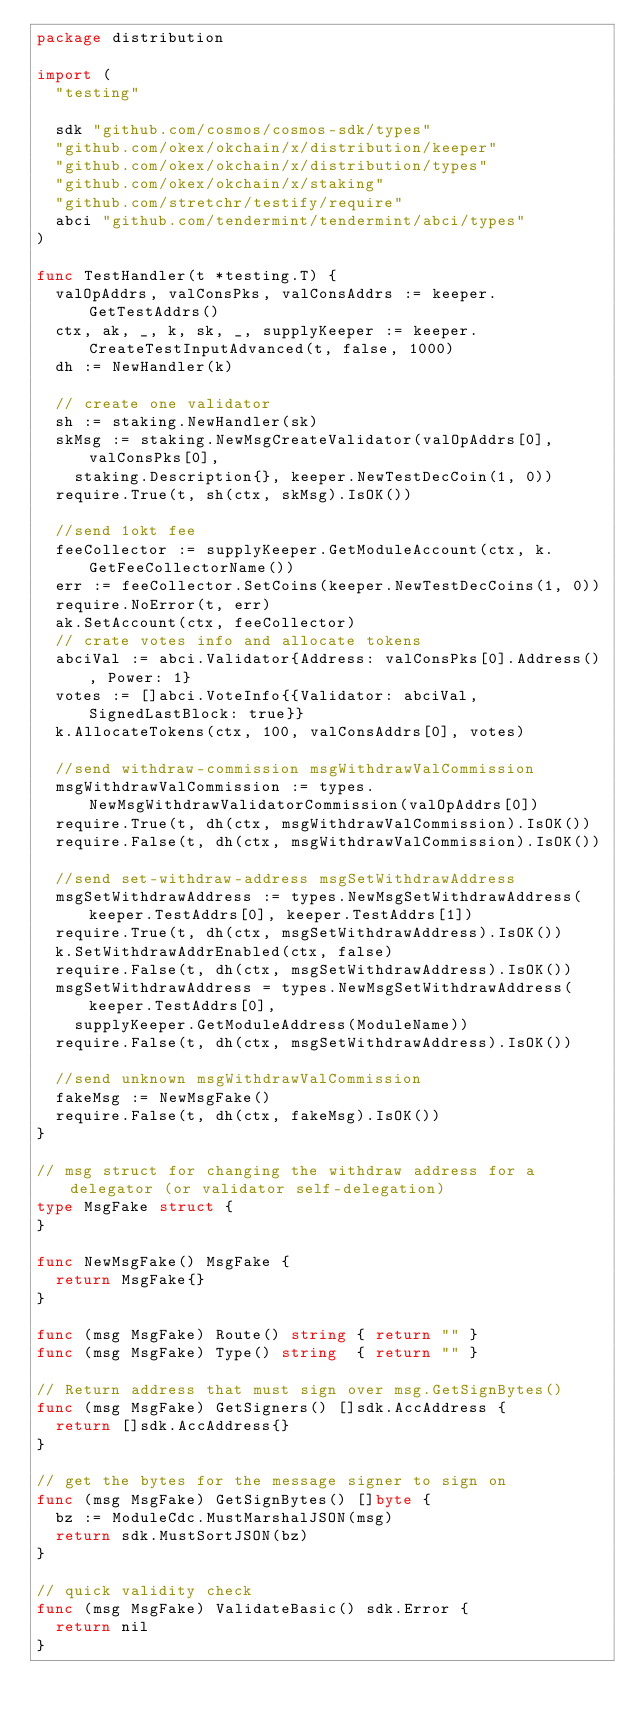<code> <loc_0><loc_0><loc_500><loc_500><_Go_>package distribution

import (
	"testing"

	sdk "github.com/cosmos/cosmos-sdk/types"
	"github.com/okex/okchain/x/distribution/keeper"
	"github.com/okex/okchain/x/distribution/types"
	"github.com/okex/okchain/x/staking"
	"github.com/stretchr/testify/require"
	abci "github.com/tendermint/tendermint/abci/types"
)

func TestHandler(t *testing.T) {
	valOpAddrs, valConsPks, valConsAddrs := keeper.GetTestAddrs()
	ctx, ak, _, k, sk, _, supplyKeeper := keeper.CreateTestInputAdvanced(t, false, 1000)
	dh := NewHandler(k)

	// create one validator
	sh := staking.NewHandler(sk)
	skMsg := staking.NewMsgCreateValidator(valOpAddrs[0], valConsPks[0],
		staking.Description{}, keeper.NewTestDecCoin(1, 0))
	require.True(t, sh(ctx, skMsg).IsOK())

	//send 1okt fee
	feeCollector := supplyKeeper.GetModuleAccount(ctx, k.GetFeeCollectorName())
	err := feeCollector.SetCoins(keeper.NewTestDecCoins(1, 0))
	require.NoError(t, err)
	ak.SetAccount(ctx, feeCollector)
	// crate votes info and allocate tokens
	abciVal := abci.Validator{Address: valConsPks[0].Address(), Power: 1}
	votes := []abci.VoteInfo{{Validator: abciVal, SignedLastBlock: true}}
	k.AllocateTokens(ctx, 100, valConsAddrs[0], votes)

	//send withdraw-commission msgWithdrawValCommission
	msgWithdrawValCommission := types.NewMsgWithdrawValidatorCommission(valOpAddrs[0])
	require.True(t, dh(ctx, msgWithdrawValCommission).IsOK())
	require.False(t, dh(ctx, msgWithdrawValCommission).IsOK())

	//send set-withdraw-address msgSetWithdrawAddress
	msgSetWithdrawAddress := types.NewMsgSetWithdrawAddress(keeper.TestAddrs[0], keeper.TestAddrs[1])
	require.True(t, dh(ctx, msgSetWithdrawAddress).IsOK())
	k.SetWithdrawAddrEnabled(ctx, false)
	require.False(t, dh(ctx, msgSetWithdrawAddress).IsOK())
	msgSetWithdrawAddress = types.NewMsgSetWithdrawAddress(keeper.TestAddrs[0],
		supplyKeeper.GetModuleAddress(ModuleName))
	require.False(t, dh(ctx, msgSetWithdrawAddress).IsOK())

	//send unknown msgWithdrawValCommission
	fakeMsg := NewMsgFake()
	require.False(t, dh(ctx, fakeMsg).IsOK())
}

// msg struct for changing the withdraw address for a delegator (or validator self-delegation)
type MsgFake struct {
}

func NewMsgFake() MsgFake {
	return MsgFake{}
}

func (msg MsgFake) Route() string { return "" }
func (msg MsgFake) Type() string  { return "" }

// Return address that must sign over msg.GetSignBytes()
func (msg MsgFake) GetSigners() []sdk.AccAddress {
	return []sdk.AccAddress{}
}

// get the bytes for the message signer to sign on
func (msg MsgFake) GetSignBytes() []byte {
	bz := ModuleCdc.MustMarshalJSON(msg)
	return sdk.MustSortJSON(bz)
}

// quick validity check
func (msg MsgFake) ValidateBasic() sdk.Error {
	return nil
}
</code> 